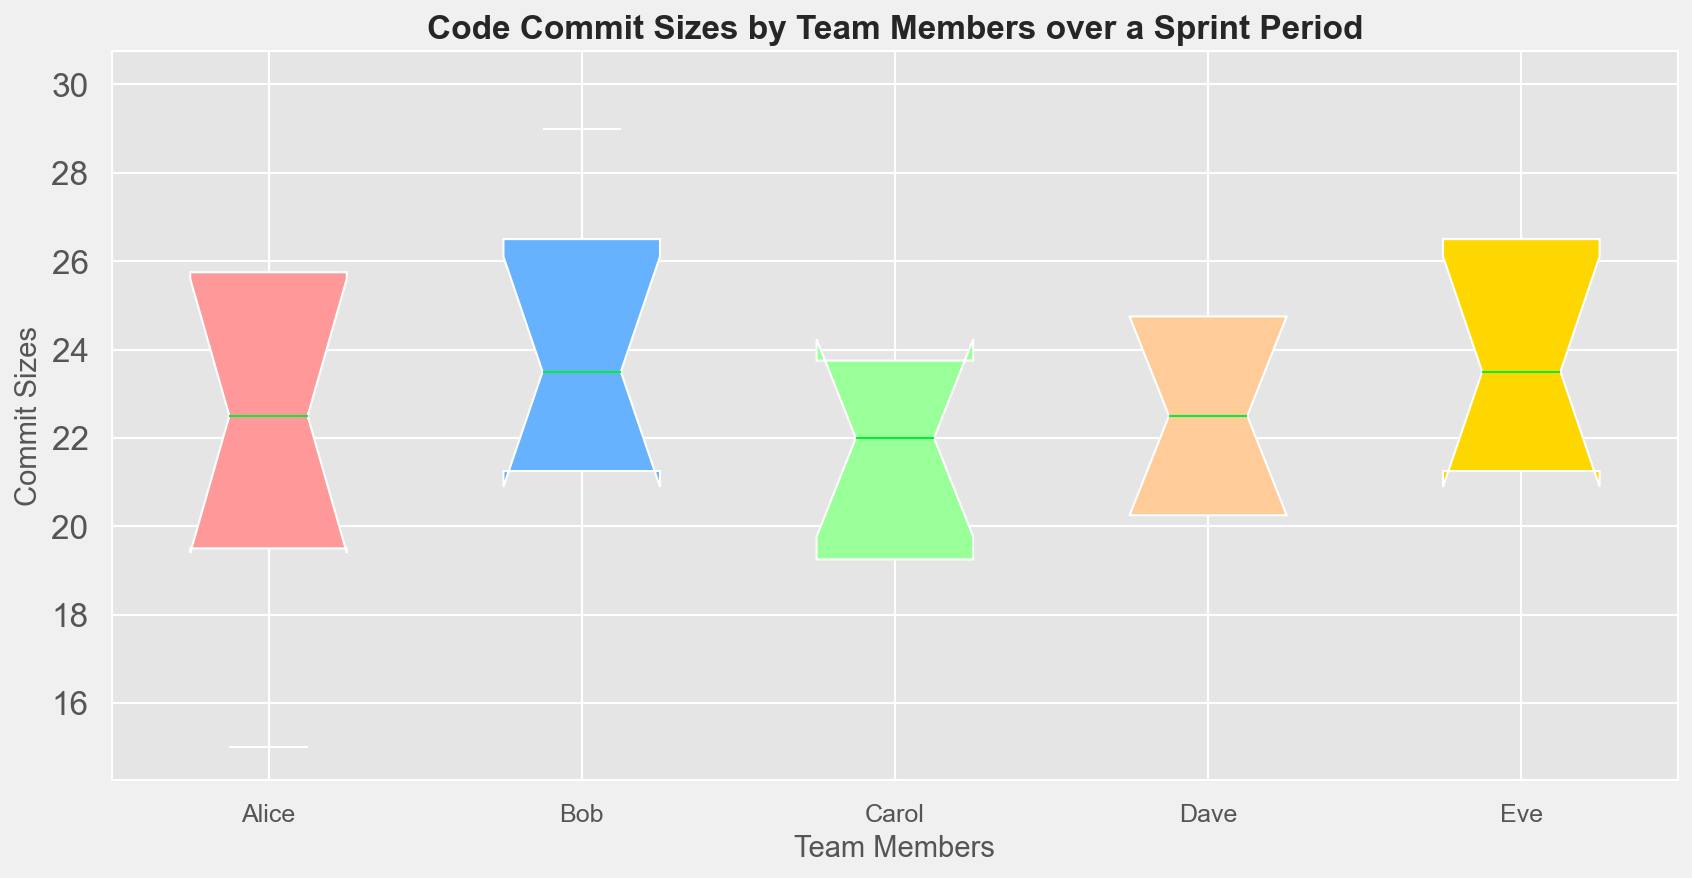How many team members' commit sizes are shown in the figure? The x-axis of the plot has labeled tick marks, each representing a team member. Count these tick marks to determine the number of team members.
Answer: 5 Which team member has the highest median commit size? The median commit size is indicated by the line inside the box of each box plot. Compare the medians of all team members and identify the highest one.
Answer: Eve Which two team members have the closest median commit sizes? Look at the lines inside the boxes to identify the position of the medians for each team member. Then compare these medians to find the two team members with the least difference between their medians.
Answer: Alice and Bob Between Alice and Bob, who has a wider interquartile range (IQR) of commit sizes? The IQR is the range between the first and third quartile, represented by the box's height. Compare the boxes' heights for Alice and Bob.
Answer: Alice Which team member has the largest range of commit sizes? The range is the difference between the highest and lowest commit size, represented by the whiskers of the box plot. Identify the team member whose whiskers span the greatest distance.
Answer: Dave Are there any outliers in the commit sizes for Carol? Outliers are depicted as individual points outside the whiskers in the box plot. Check Carol's box plot to see if any points lie outside the whiskers.
Answer: No What's the median commit size for Eve? The median is the line inside the box of Eve's box plot. Determine its value by checking the y-axis at Eve's median line.
Answer: 24 Which team member has the smallest spread of commit sizes? The spread is indicated by the overall height of the box and whiskers. Identify the team member whose box plot has the shortest whiskers and box.
Answer: Bob Between Dave and Eve, whose commit sizes are more skewed? Skewness can be inferred from the asymmetry of the box plot. Compare how the boxes and whiskers of Dave and Eve are distributed around the median to infer skewness.
Answer: Dave Which team member has the most balanced commit sizes between the upper and lower quartiles? Balance can be identified if the median is roughly in the middle of the box, and the whiskers are of similar length. Compare all team members to find the most balanced one.
Answer: Carol 